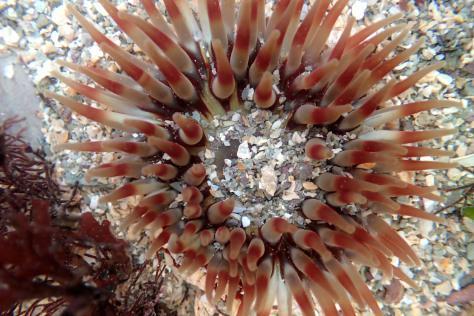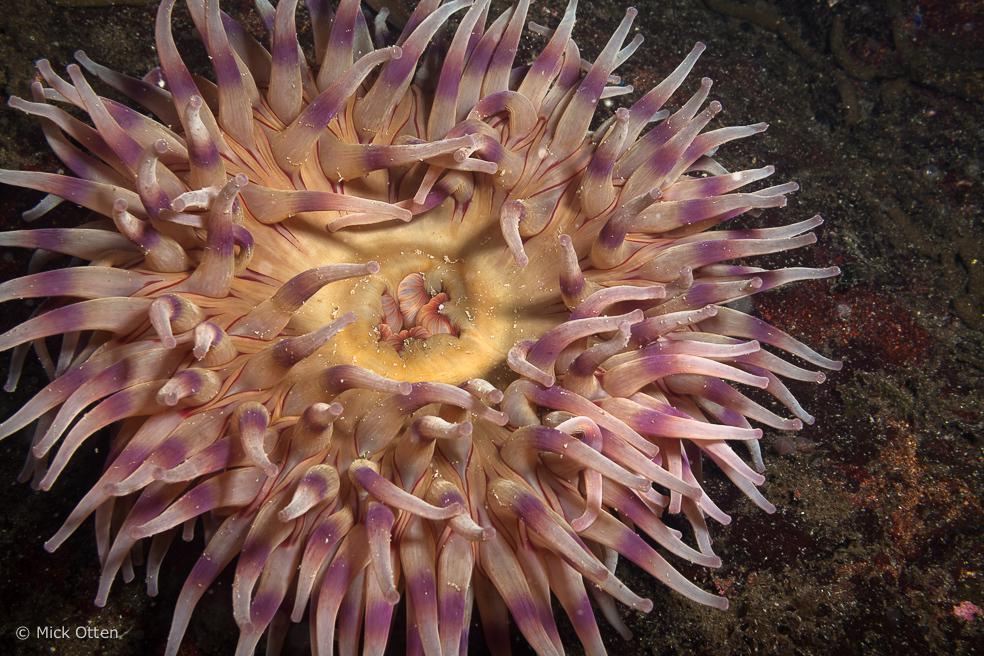The first image is the image on the left, the second image is the image on the right. For the images shown, is this caption "At least one of the organisms is a spherical shape." true? Answer yes or no. No. The first image is the image on the left, the second image is the image on the right. Evaluate the accuracy of this statement regarding the images: "Each image contains one prominent roundish marine creature, and the image on the left shows an anemone with tapered orangish tendrils radiating from a center.". Is it true? Answer yes or no. Yes. 